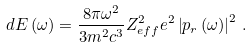Convert formula to latex. <formula><loc_0><loc_0><loc_500><loc_500>d E \left ( \omega \right ) = \frac { 8 \pi \omega ^ { 2 } } { 3 m ^ { 2 } c ^ { 3 } } Z _ { e f f } ^ { 2 } e ^ { 2 } \left | p _ { r } \left ( \omega \right ) \right | ^ { 2 } \, .</formula> 